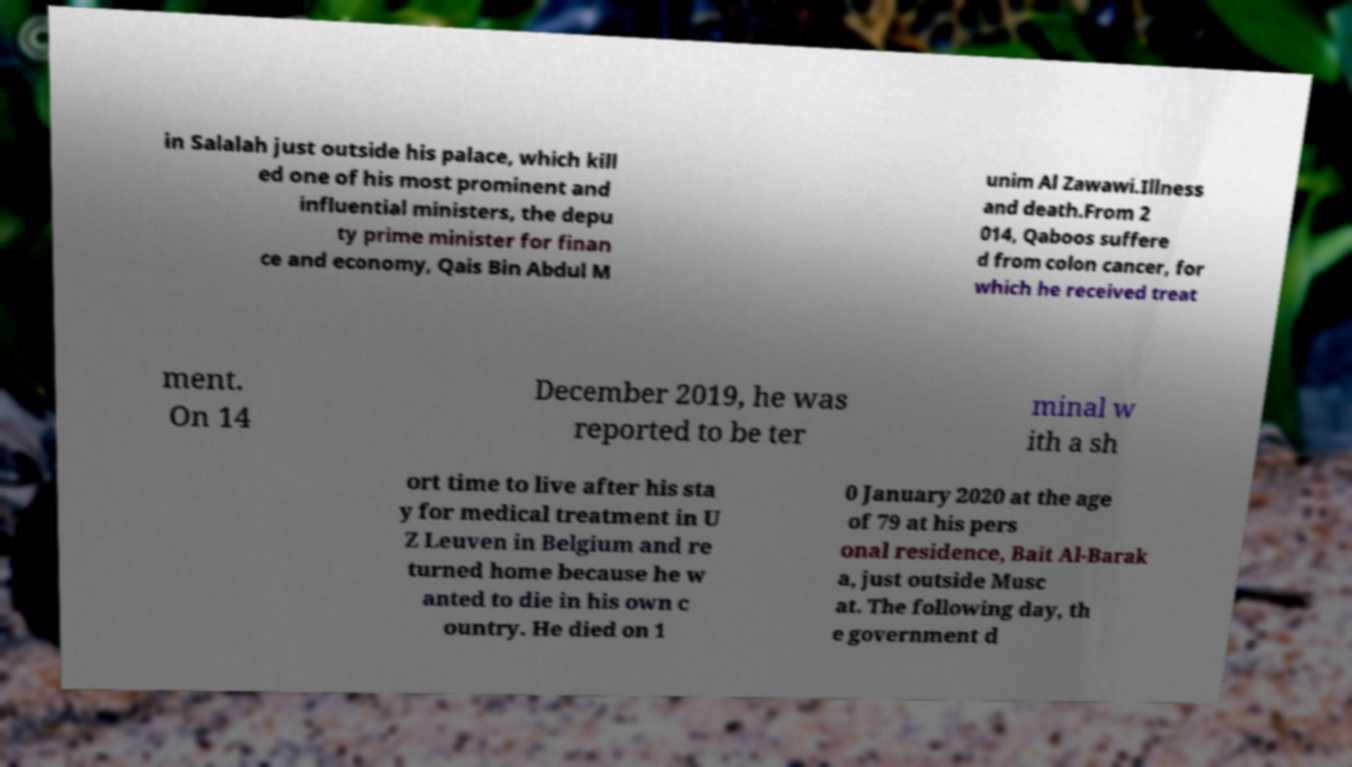Can you read and provide the text displayed in the image?This photo seems to have some interesting text. Can you extract and type it out for me? in Salalah just outside his palace, which kill ed one of his most prominent and influential ministers, the depu ty prime minister for finan ce and economy, Qais Bin Abdul M unim Al Zawawi.Illness and death.From 2 014, Qaboos suffere d from colon cancer, for which he received treat ment. On 14 December 2019, he was reported to be ter minal w ith a sh ort time to live after his sta y for medical treatment in U Z Leuven in Belgium and re turned home because he w anted to die in his own c ountry. He died on 1 0 January 2020 at the age of 79 at his pers onal residence, Bait Al-Barak a, just outside Musc at. The following day, th e government d 